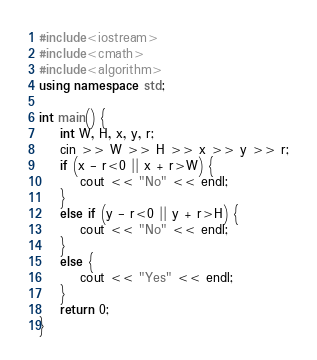Convert code to text. <code><loc_0><loc_0><loc_500><loc_500><_C++_>#include<iostream>
#include<cmath>
#include<algorithm>
using namespace std;

int main() {
	int W, H, x, y, r;
	cin >> W >> H >> x >> y >> r;
	if (x - r<0 || x + r>W) {
		cout << "No" << endl;
	}
	else if (y - r<0 || y + r>H) {
		cout << "No" << endl;
	}
	else {
		cout << "Yes" << endl;
	}
	return 0;
}
</code> 